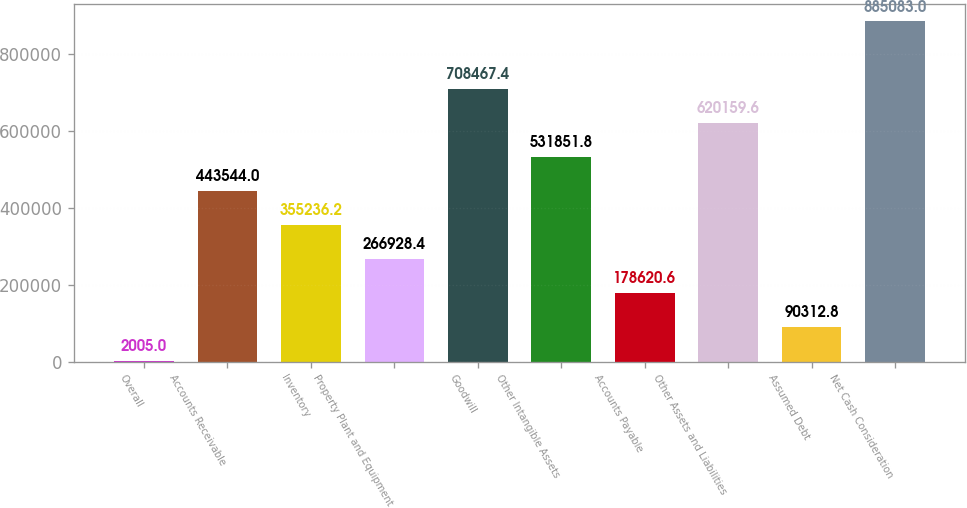Convert chart. <chart><loc_0><loc_0><loc_500><loc_500><bar_chart><fcel>Overall<fcel>Accounts Receivable<fcel>Inventory<fcel>Property Plant and Equipment<fcel>Goodwill<fcel>Other Intangible Assets<fcel>Accounts Payable<fcel>Other Assets and Liabilities<fcel>Assumed Debt<fcel>Net Cash Consideration<nl><fcel>2005<fcel>443544<fcel>355236<fcel>266928<fcel>708467<fcel>531852<fcel>178621<fcel>620160<fcel>90312.8<fcel>885083<nl></chart> 